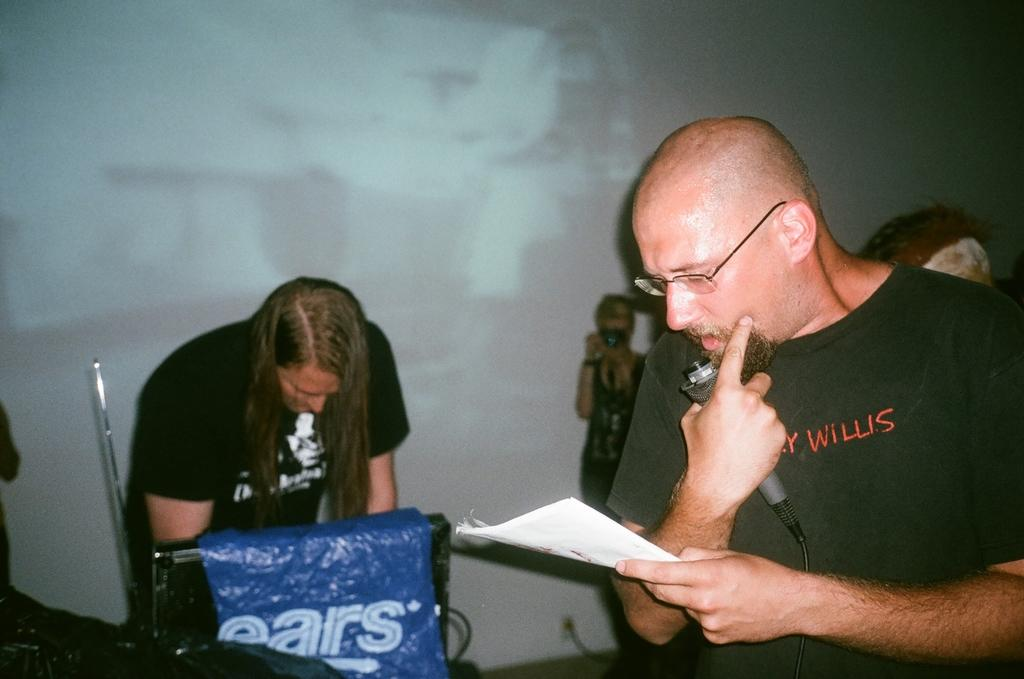How many people are in the image? There are people in the image. Can you describe what one of the people is holding? One person is holding a book in their hand. Where is the other person located in the image? There is another person on the left side of the image. What type of badge is the person wearing on their shirt in the image? There is no badge visible on anyone's shirt in the image. What road can be seen in the background of the image? There is no road present in the image. 